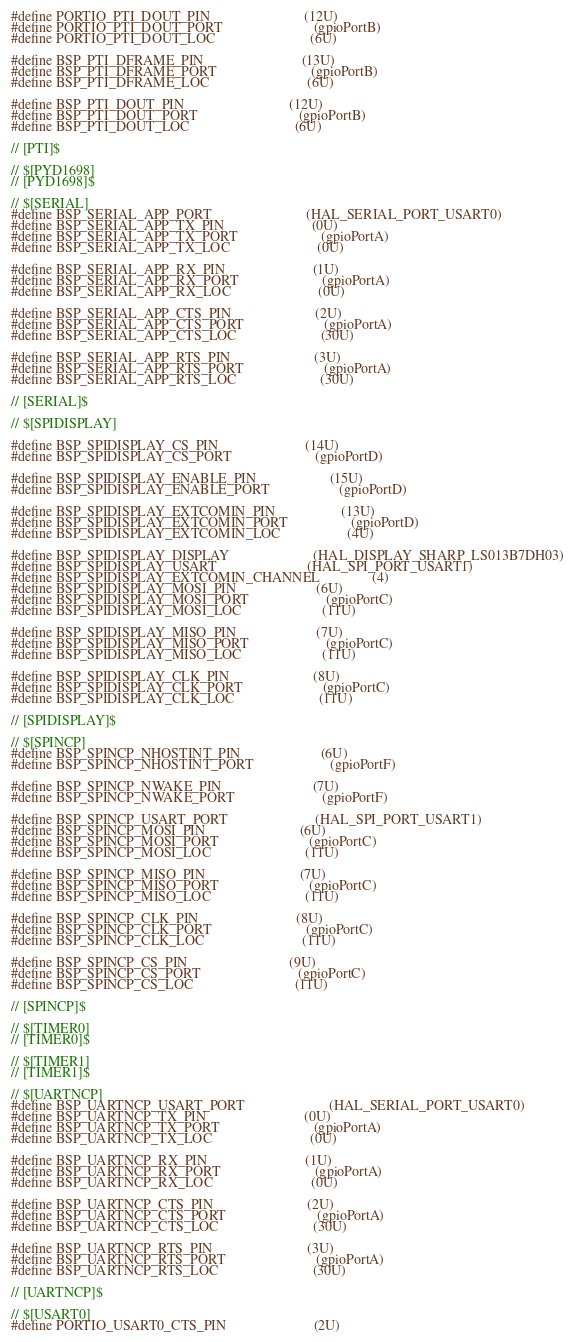<code> <loc_0><loc_0><loc_500><loc_500><_C_>#define PORTIO_PTI_DOUT_PIN                           (12U)
#define PORTIO_PTI_DOUT_PORT                          (gpioPortB)
#define PORTIO_PTI_DOUT_LOC                           (6U)

#define BSP_PTI_DFRAME_PIN                            (13U)
#define BSP_PTI_DFRAME_PORT                           (gpioPortB)
#define BSP_PTI_DFRAME_LOC                            (6U)

#define BSP_PTI_DOUT_PIN                              (12U)
#define BSP_PTI_DOUT_PORT                             (gpioPortB)
#define BSP_PTI_DOUT_LOC                              (6U)

// [PTI]$

// $[PYD1698]
// [PYD1698]$

// $[SERIAL]
#define BSP_SERIAL_APP_PORT                           (HAL_SERIAL_PORT_USART0)
#define BSP_SERIAL_APP_TX_PIN                         (0U)
#define BSP_SERIAL_APP_TX_PORT                        (gpioPortA)
#define BSP_SERIAL_APP_TX_LOC                         (0U)

#define BSP_SERIAL_APP_RX_PIN                         (1U)
#define BSP_SERIAL_APP_RX_PORT                        (gpioPortA)
#define BSP_SERIAL_APP_RX_LOC                         (0U)

#define BSP_SERIAL_APP_CTS_PIN                        (2U)
#define BSP_SERIAL_APP_CTS_PORT                       (gpioPortA)
#define BSP_SERIAL_APP_CTS_LOC                        (30U)

#define BSP_SERIAL_APP_RTS_PIN                        (3U)
#define BSP_SERIAL_APP_RTS_PORT                       (gpioPortA)
#define BSP_SERIAL_APP_RTS_LOC                        (30U)

// [SERIAL]$

// $[SPIDISPLAY]

#define BSP_SPIDISPLAY_CS_PIN                         (14U)
#define BSP_SPIDISPLAY_CS_PORT                        (gpioPortD)

#define BSP_SPIDISPLAY_ENABLE_PIN                     (15U)
#define BSP_SPIDISPLAY_ENABLE_PORT                    (gpioPortD)

#define BSP_SPIDISPLAY_EXTCOMIN_PIN                   (13U)
#define BSP_SPIDISPLAY_EXTCOMIN_PORT                  (gpioPortD)
#define BSP_SPIDISPLAY_EXTCOMIN_LOC                   (4U)

#define BSP_SPIDISPLAY_DISPLAY                        (HAL_DISPLAY_SHARP_LS013B7DH03)
#define BSP_SPIDISPLAY_USART                          (HAL_SPI_PORT_USART1)
#define BSP_SPIDISPLAY_EXTCOMIN_CHANNEL               (4)
#define BSP_SPIDISPLAY_MOSI_PIN                       (6U)
#define BSP_SPIDISPLAY_MOSI_PORT                      (gpioPortC)
#define BSP_SPIDISPLAY_MOSI_LOC                       (11U)

#define BSP_SPIDISPLAY_MISO_PIN                       (7U)
#define BSP_SPIDISPLAY_MISO_PORT                      (gpioPortC)
#define BSP_SPIDISPLAY_MISO_LOC                       (11U)

#define BSP_SPIDISPLAY_CLK_PIN                        (8U)
#define BSP_SPIDISPLAY_CLK_PORT                       (gpioPortC)
#define BSP_SPIDISPLAY_CLK_LOC                        (11U)

// [SPIDISPLAY]$

// $[SPINCP]
#define BSP_SPINCP_NHOSTINT_PIN                       (6U)
#define BSP_SPINCP_NHOSTINT_PORT                      (gpioPortF)

#define BSP_SPINCP_NWAKE_PIN                          (7U)
#define BSP_SPINCP_NWAKE_PORT                         (gpioPortF)

#define BSP_SPINCP_USART_PORT                         (HAL_SPI_PORT_USART1)
#define BSP_SPINCP_MOSI_PIN                           (6U)
#define BSP_SPINCP_MOSI_PORT                          (gpioPortC)
#define BSP_SPINCP_MOSI_LOC                           (11U)

#define BSP_SPINCP_MISO_PIN                           (7U)
#define BSP_SPINCP_MISO_PORT                          (gpioPortC)
#define BSP_SPINCP_MISO_LOC                           (11U)

#define BSP_SPINCP_CLK_PIN                            (8U)
#define BSP_SPINCP_CLK_PORT                           (gpioPortC)
#define BSP_SPINCP_CLK_LOC                            (11U)

#define BSP_SPINCP_CS_PIN                             (9U)
#define BSP_SPINCP_CS_PORT                            (gpioPortC)
#define BSP_SPINCP_CS_LOC                             (11U)

// [SPINCP]$

// $[TIMER0]
// [TIMER0]$

// $[TIMER1]
// [TIMER1]$

// $[UARTNCP]
#define BSP_UARTNCP_USART_PORT                        (HAL_SERIAL_PORT_USART0)
#define BSP_UARTNCP_TX_PIN                            (0U)
#define BSP_UARTNCP_TX_PORT                           (gpioPortA)
#define BSP_UARTNCP_TX_LOC                            (0U)

#define BSP_UARTNCP_RX_PIN                            (1U)
#define BSP_UARTNCP_RX_PORT                           (gpioPortA)
#define BSP_UARTNCP_RX_LOC                            (0U)

#define BSP_UARTNCP_CTS_PIN                           (2U)
#define BSP_UARTNCP_CTS_PORT                          (gpioPortA)
#define BSP_UARTNCP_CTS_LOC                           (30U)

#define BSP_UARTNCP_RTS_PIN                           (3U)
#define BSP_UARTNCP_RTS_PORT                          (gpioPortA)
#define BSP_UARTNCP_RTS_LOC                           (30U)

// [UARTNCP]$

// $[USART0]
#define PORTIO_USART0_CTS_PIN                         (2U)</code> 